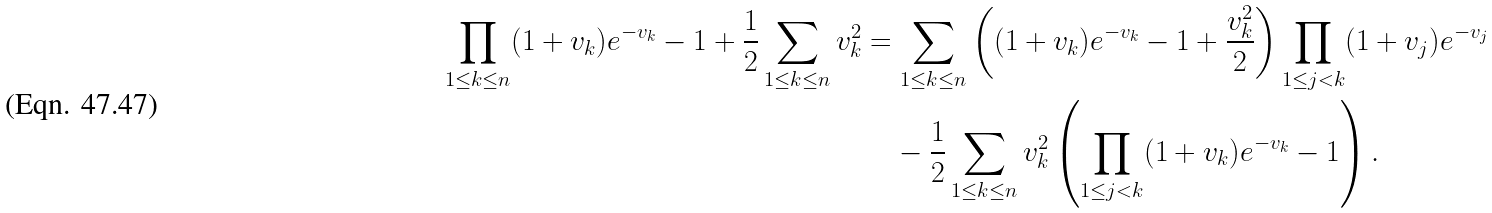Convert formula to latex. <formula><loc_0><loc_0><loc_500><loc_500>\prod _ { 1 \leq k \leq n } ( 1 + v _ { k } ) e ^ { - v _ { k } } - 1 + \frac { 1 } { 2 } \sum _ { 1 \leq k \leq n } v _ { k } ^ { 2 } & = \sum _ { 1 \leq k \leq n } \left ( ( 1 + v _ { k } ) e ^ { - v _ { k } } - 1 + \frac { v _ { k } ^ { 2 } } { 2 } \right ) \prod _ { 1 \leq j < k } ( 1 + v _ { j } ) e ^ { - v _ { j } } \\ & \quad - \frac { 1 } { 2 } \sum _ { 1 \leq k \leq n } v _ { k } ^ { 2 } \left ( \prod _ { 1 \leq j < k } ( 1 + v _ { k } ) e ^ { - v _ { k } } - 1 \right ) .</formula> 